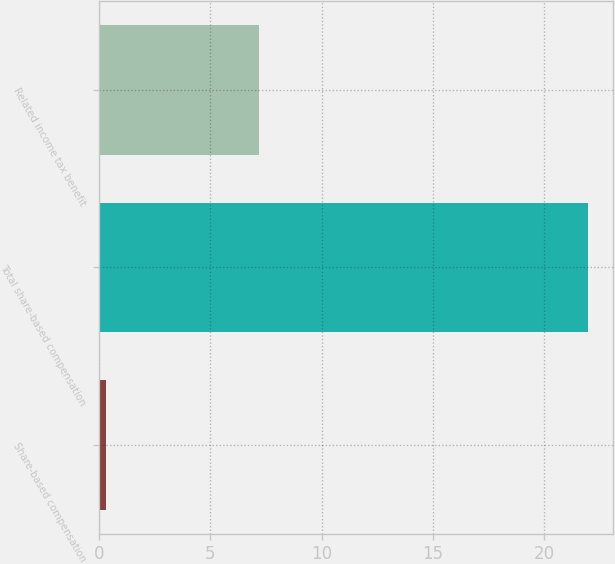Convert chart. <chart><loc_0><loc_0><loc_500><loc_500><bar_chart><fcel>Share-based compensation<fcel>Total share-based compensation<fcel>Related income tax benefit<nl><fcel>0.3<fcel>22<fcel>7.2<nl></chart> 